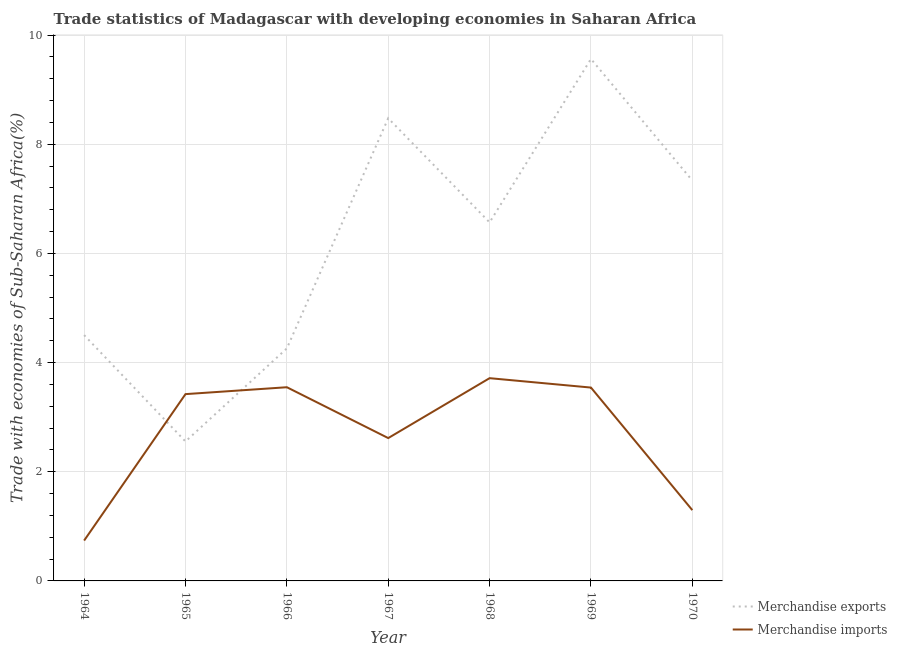How many different coloured lines are there?
Your answer should be very brief. 2. What is the merchandise imports in 1964?
Your answer should be compact. 0.74. Across all years, what is the maximum merchandise imports?
Offer a very short reply. 3.71. Across all years, what is the minimum merchandise imports?
Provide a succinct answer. 0.74. In which year was the merchandise exports maximum?
Make the answer very short. 1969. In which year was the merchandise imports minimum?
Your answer should be very brief. 1964. What is the total merchandise imports in the graph?
Provide a succinct answer. 18.88. What is the difference between the merchandise exports in 1965 and that in 1966?
Give a very brief answer. -1.7. What is the difference between the merchandise exports in 1967 and the merchandise imports in 1970?
Your answer should be compact. 7.18. What is the average merchandise exports per year?
Provide a succinct answer. 6.18. In the year 1968, what is the difference between the merchandise exports and merchandise imports?
Offer a terse response. 2.85. What is the ratio of the merchandise exports in 1965 to that in 1970?
Your answer should be very brief. 0.35. Is the merchandise imports in 1965 less than that in 1969?
Your response must be concise. Yes. Is the difference between the merchandise exports in 1964 and 1968 greater than the difference between the merchandise imports in 1964 and 1968?
Your answer should be very brief. Yes. What is the difference between the highest and the second highest merchandise imports?
Provide a succinct answer. 0.17. What is the difference between the highest and the lowest merchandise exports?
Your response must be concise. 7.01. Is the sum of the merchandise exports in 1964 and 1966 greater than the maximum merchandise imports across all years?
Give a very brief answer. Yes. Is the merchandise exports strictly less than the merchandise imports over the years?
Keep it short and to the point. No. How many lines are there?
Provide a succinct answer. 2. How many years are there in the graph?
Ensure brevity in your answer.  7. Are the values on the major ticks of Y-axis written in scientific E-notation?
Keep it short and to the point. No. Where does the legend appear in the graph?
Make the answer very short. Bottom right. How many legend labels are there?
Provide a succinct answer. 2. What is the title of the graph?
Keep it short and to the point. Trade statistics of Madagascar with developing economies in Saharan Africa. Does "Rural Population" appear as one of the legend labels in the graph?
Provide a short and direct response. No. What is the label or title of the Y-axis?
Make the answer very short. Trade with economies of Sub-Saharan Africa(%). What is the Trade with economies of Sub-Saharan Africa(%) in Merchandise exports in 1964?
Your response must be concise. 4.5. What is the Trade with economies of Sub-Saharan Africa(%) in Merchandise imports in 1964?
Your response must be concise. 0.74. What is the Trade with economies of Sub-Saharan Africa(%) of Merchandise exports in 1965?
Provide a short and direct response. 2.56. What is the Trade with economies of Sub-Saharan Africa(%) in Merchandise imports in 1965?
Provide a short and direct response. 3.42. What is the Trade with economies of Sub-Saharan Africa(%) of Merchandise exports in 1966?
Your response must be concise. 4.26. What is the Trade with economies of Sub-Saharan Africa(%) in Merchandise imports in 1966?
Give a very brief answer. 3.55. What is the Trade with economies of Sub-Saharan Africa(%) of Merchandise exports in 1967?
Give a very brief answer. 8.48. What is the Trade with economies of Sub-Saharan Africa(%) in Merchandise imports in 1967?
Ensure brevity in your answer.  2.62. What is the Trade with economies of Sub-Saharan Africa(%) of Merchandise exports in 1968?
Your answer should be very brief. 6.57. What is the Trade with economies of Sub-Saharan Africa(%) in Merchandise imports in 1968?
Provide a succinct answer. 3.71. What is the Trade with economies of Sub-Saharan Africa(%) of Merchandise exports in 1969?
Offer a terse response. 9.56. What is the Trade with economies of Sub-Saharan Africa(%) in Merchandise imports in 1969?
Provide a succinct answer. 3.54. What is the Trade with economies of Sub-Saharan Africa(%) in Merchandise exports in 1970?
Provide a succinct answer. 7.34. What is the Trade with economies of Sub-Saharan Africa(%) of Merchandise imports in 1970?
Offer a very short reply. 1.3. Across all years, what is the maximum Trade with economies of Sub-Saharan Africa(%) of Merchandise exports?
Your answer should be very brief. 9.56. Across all years, what is the maximum Trade with economies of Sub-Saharan Africa(%) in Merchandise imports?
Provide a succinct answer. 3.71. Across all years, what is the minimum Trade with economies of Sub-Saharan Africa(%) in Merchandise exports?
Offer a very short reply. 2.56. Across all years, what is the minimum Trade with economies of Sub-Saharan Africa(%) in Merchandise imports?
Provide a short and direct response. 0.74. What is the total Trade with economies of Sub-Saharan Africa(%) in Merchandise exports in the graph?
Ensure brevity in your answer.  43.26. What is the total Trade with economies of Sub-Saharan Africa(%) of Merchandise imports in the graph?
Offer a very short reply. 18.88. What is the difference between the Trade with economies of Sub-Saharan Africa(%) of Merchandise exports in 1964 and that in 1965?
Ensure brevity in your answer.  1.95. What is the difference between the Trade with economies of Sub-Saharan Africa(%) in Merchandise imports in 1964 and that in 1965?
Provide a short and direct response. -2.68. What is the difference between the Trade with economies of Sub-Saharan Africa(%) in Merchandise exports in 1964 and that in 1966?
Your answer should be very brief. 0.24. What is the difference between the Trade with economies of Sub-Saharan Africa(%) of Merchandise imports in 1964 and that in 1966?
Offer a very short reply. -2.81. What is the difference between the Trade with economies of Sub-Saharan Africa(%) in Merchandise exports in 1964 and that in 1967?
Your answer should be compact. -3.97. What is the difference between the Trade with economies of Sub-Saharan Africa(%) in Merchandise imports in 1964 and that in 1967?
Make the answer very short. -1.88. What is the difference between the Trade with economies of Sub-Saharan Africa(%) of Merchandise exports in 1964 and that in 1968?
Provide a succinct answer. -2.07. What is the difference between the Trade with economies of Sub-Saharan Africa(%) in Merchandise imports in 1964 and that in 1968?
Keep it short and to the point. -2.98. What is the difference between the Trade with economies of Sub-Saharan Africa(%) of Merchandise exports in 1964 and that in 1969?
Ensure brevity in your answer.  -5.06. What is the difference between the Trade with economies of Sub-Saharan Africa(%) of Merchandise imports in 1964 and that in 1969?
Offer a terse response. -2.8. What is the difference between the Trade with economies of Sub-Saharan Africa(%) in Merchandise exports in 1964 and that in 1970?
Make the answer very short. -2.83. What is the difference between the Trade with economies of Sub-Saharan Africa(%) of Merchandise imports in 1964 and that in 1970?
Ensure brevity in your answer.  -0.56. What is the difference between the Trade with economies of Sub-Saharan Africa(%) of Merchandise exports in 1965 and that in 1966?
Your response must be concise. -1.7. What is the difference between the Trade with economies of Sub-Saharan Africa(%) in Merchandise imports in 1965 and that in 1966?
Offer a terse response. -0.13. What is the difference between the Trade with economies of Sub-Saharan Africa(%) in Merchandise exports in 1965 and that in 1967?
Offer a terse response. -5.92. What is the difference between the Trade with economies of Sub-Saharan Africa(%) in Merchandise imports in 1965 and that in 1967?
Keep it short and to the point. 0.81. What is the difference between the Trade with economies of Sub-Saharan Africa(%) in Merchandise exports in 1965 and that in 1968?
Ensure brevity in your answer.  -4.01. What is the difference between the Trade with economies of Sub-Saharan Africa(%) of Merchandise imports in 1965 and that in 1968?
Keep it short and to the point. -0.29. What is the difference between the Trade with economies of Sub-Saharan Africa(%) in Merchandise exports in 1965 and that in 1969?
Provide a succinct answer. -7.01. What is the difference between the Trade with economies of Sub-Saharan Africa(%) of Merchandise imports in 1965 and that in 1969?
Provide a short and direct response. -0.12. What is the difference between the Trade with economies of Sub-Saharan Africa(%) of Merchandise exports in 1965 and that in 1970?
Your response must be concise. -4.78. What is the difference between the Trade with economies of Sub-Saharan Africa(%) of Merchandise imports in 1965 and that in 1970?
Give a very brief answer. 2.13. What is the difference between the Trade with economies of Sub-Saharan Africa(%) of Merchandise exports in 1966 and that in 1967?
Ensure brevity in your answer.  -4.22. What is the difference between the Trade with economies of Sub-Saharan Africa(%) in Merchandise imports in 1966 and that in 1967?
Offer a terse response. 0.93. What is the difference between the Trade with economies of Sub-Saharan Africa(%) in Merchandise exports in 1966 and that in 1968?
Your answer should be compact. -2.31. What is the difference between the Trade with economies of Sub-Saharan Africa(%) of Merchandise imports in 1966 and that in 1968?
Provide a succinct answer. -0.17. What is the difference between the Trade with economies of Sub-Saharan Africa(%) in Merchandise exports in 1966 and that in 1969?
Keep it short and to the point. -5.3. What is the difference between the Trade with economies of Sub-Saharan Africa(%) in Merchandise imports in 1966 and that in 1969?
Offer a terse response. 0.01. What is the difference between the Trade with economies of Sub-Saharan Africa(%) of Merchandise exports in 1966 and that in 1970?
Your response must be concise. -3.08. What is the difference between the Trade with economies of Sub-Saharan Africa(%) in Merchandise imports in 1966 and that in 1970?
Offer a terse response. 2.25. What is the difference between the Trade with economies of Sub-Saharan Africa(%) of Merchandise exports in 1967 and that in 1968?
Your response must be concise. 1.91. What is the difference between the Trade with economies of Sub-Saharan Africa(%) of Merchandise imports in 1967 and that in 1968?
Keep it short and to the point. -1.1. What is the difference between the Trade with economies of Sub-Saharan Africa(%) in Merchandise exports in 1967 and that in 1969?
Provide a succinct answer. -1.09. What is the difference between the Trade with economies of Sub-Saharan Africa(%) of Merchandise imports in 1967 and that in 1969?
Give a very brief answer. -0.93. What is the difference between the Trade with economies of Sub-Saharan Africa(%) in Merchandise exports in 1967 and that in 1970?
Your answer should be compact. 1.14. What is the difference between the Trade with economies of Sub-Saharan Africa(%) in Merchandise imports in 1967 and that in 1970?
Your answer should be very brief. 1.32. What is the difference between the Trade with economies of Sub-Saharan Africa(%) of Merchandise exports in 1968 and that in 1969?
Your answer should be compact. -2.99. What is the difference between the Trade with economies of Sub-Saharan Africa(%) in Merchandise imports in 1968 and that in 1969?
Your answer should be compact. 0.17. What is the difference between the Trade with economies of Sub-Saharan Africa(%) of Merchandise exports in 1968 and that in 1970?
Your response must be concise. -0.77. What is the difference between the Trade with economies of Sub-Saharan Africa(%) of Merchandise imports in 1968 and that in 1970?
Your answer should be very brief. 2.42. What is the difference between the Trade with economies of Sub-Saharan Africa(%) in Merchandise exports in 1969 and that in 1970?
Make the answer very short. 2.23. What is the difference between the Trade with economies of Sub-Saharan Africa(%) of Merchandise imports in 1969 and that in 1970?
Your answer should be very brief. 2.25. What is the difference between the Trade with economies of Sub-Saharan Africa(%) in Merchandise exports in 1964 and the Trade with economies of Sub-Saharan Africa(%) in Merchandise imports in 1965?
Your response must be concise. 1.08. What is the difference between the Trade with economies of Sub-Saharan Africa(%) in Merchandise exports in 1964 and the Trade with economies of Sub-Saharan Africa(%) in Merchandise imports in 1966?
Make the answer very short. 0.95. What is the difference between the Trade with economies of Sub-Saharan Africa(%) of Merchandise exports in 1964 and the Trade with economies of Sub-Saharan Africa(%) of Merchandise imports in 1967?
Provide a succinct answer. 1.89. What is the difference between the Trade with economies of Sub-Saharan Africa(%) of Merchandise exports in 1964 and the Trade with economies of Sub-Saharan Africa(%) of Merchandise imports in 1968?
Make the answer very short. 0.79. What is the difference between the Trade with economies of Sub-Saharan Africa(%) in Merchandise exports in 1964 and the Trade with economies of Sub-Saharan Africa(%) in Merchandise imports in 1969?
Provide a succinct answer. 0.96. What is the difference between the Trade with economies of Sub-Saharan Africa(%) in Merchandise exports in 1964 and the Trade with economies of Sub-Saharan Africa(%) in Merchandise imports in 1970?
Offer a terse response. 3.21. What is the difference between the Trade with economies of Sub-Saharan Africa(%) of Merchandise exports in 1965 and the Trade with economies of Sub-Saharan Africa(%) of Merchandise imports in 1966?
Provide a succinct answer. -0.99. What is the difference between the Trade with economies of Sub-Saharan Africa(%) in Merchandise exports in 1965 and the Trade with economies of Sub-Saharan Africa(%) in Merchandise imports in 1967?
Keep it short and to the point. -0.06. What is the difference between the Trade with economies of Sub-Saharan Africa(%) in Merchandise exports in 1965 and the Trade with economies of Sub-Saharan Africa(%) in Merchandise imports in 1968?
Your response must be concise. -1.16. What is the difference between the Trade with economies of Sub-Saharan Africa(%) in Merchandise exports in 1965 and the Trade with economies of Sub-Saharan Africa(%) in Merchandise imports in 1969?
Make the answer very short. -0.99. What is the difference between the Trade with economies of Sub-Saharan Africa(%) in Merchandise exports in 1965 and the Trade with economies of Sub-Saharan Africa(%) in Merchandise imports in 1970?
Make the answer very short. 1.26. What is the difference between the Trade with economies of Sub-Saharan Africa(%) in Merchandise exports in 1966 and the Trade with economies of Sub-Saharan Africa(%) in Merchandise imports in 1967?
Give a very brief answer. 1.64. What is the difference between the Trade with economies of Sub-Saharan Africa(%) of Merchandise exports in 1966 and the Trade with economies of Sub-Saharan Africa(%) of Merchandise imports in 1968?
Your response must be concise. 0.55. What is the difference between the Trade with economies of Sub-Saharan Africa(%) of Merchandise exports in 1966 and the Trade with economies of Sub-Saharan Africa(%) of Merchandise imports in 1969?
Your answer should be compact. 0.72. What is the difference between the Trade with economies of Sub-Saharan Africa(%) in Merchandise exports in 1966 and the Trade with economies of Sub-Saharan Africa(%) in Merchandise imports in 1970?
Your response must be concise. 2.96. What is the difference between the Trade with economies of Sub-Saharan Africa(%) of Merchandise exports in 1967 and the Trade with economies of Sub-Saharan Africa(%) of Merchandise imports in 1968?
Give a very brief answer. 4.76. What is the difference between the Trade with economies of Sub-Saharan Africa(%) of Merchandise exports in 1967 and the Trade with economies of Sub-Saharan Africa(%) of Merchandise imports in 1969?
Your answer should be very brief. 4.93. What is the difference between the Trade with economies of Sub-Saharan Africa(%) of Merchandise exports in 1967 and the Trade with economies of Sub-Saharan Africa(%) of Merchandise imports in 1970?
Offer a very short reply. 7.18. What is the difference between the Trade with economies of Sub-Saharan Africa(%) in Merchandise exports in 1968 and the Trade with economies of Sub-Saharan Africa(%) in Merchandise imports in 1969?
Give a very brief answer. 3.03. What is the difference between the Trade with economies of Sub-Saharan Africa(%) of Merchandise exports in 1968 and the Trade with economies of Sub-Saharan Africa(%) of Merchandise imports in 1970?
Provide a succinct answer. 5.27. What is the difference between the Trade with economies of Sub-Saharan Africa(%) of Merchandise exports in 1969 and the Trade with economies of Sub-Saharan Africa(%) of Merchandise imports in 1970?
Give a very brief answer. 8.27. What is the average Trade with economies of Sub-Saharan Africa(%) in Merchandise exports per year?
Give a very brief answer. 6.18. What is the average Trade with economies of Sub-Saharan Africa(%) of Merchandise imports per year?
Keep it short and to the point. 2.7. In the year 1964, what is the difference between the Trade with economies of Sub-Saharan Africa(%) in Merchandise exports and Trade with economies of Sub-Saharan Africa(%) in Merchandise imports?
Give a very brief answer. 3.76. In the year 1965, what is the difference between the Trade with economies of Sub-Saharan Africa(%) in Merchandise exports and Trade with economies of Sub-Saharan Africa(%) in Merchandise imports?
Your answer should be very brief. -0.87. In the year 1966, what is the difference between the Trade with economies of Sub-Saharan Africa(%) in Merchandise exports and Trade with economies of Sub-Saharan Africa(%) in Merchandise imports?
Give a very brief answer. 0.71. In the year 1967, what is the difference between the Trade with economies of Sub-Saharan Africa(%) in Merchandise exports and Trade with economies of Sub-Saharan Africa(%) in Merchandise imports?
Provide a short and direct response. 5.86. In the year 1968, what is the difference between the Trade with economies of Sub-Saharan Africa(%) of Merchandise exports and Trade with economies of Sub-Saharan Africa(%) of Merchandise imports?
Your answer should be compact. 2.85. In the year 1969, what is the difference between the Trade with economies of Sub-Saharan Africa(%) of Merchandise exports and Trade with economies of Sub-Saharan Africa(%) of Merchandise imports?
Make the answer very short. 6.02. In the year 1970, what is the difference between the Trade with economies of Sub-Saharan Africa(%) of Merchandise exports and Trade with economies of Sub-Saharan Africa(%) of Merchandise imports?
Offer a very short reply. 6.04. What is the ratio of the Trade with economies of Sub-Saharan Africa(%) of Merchandise exports in 1964 to that in 1965?
Provide a succinct answer. 1.76. What is the ratio of the Trade with economies of Sub-Saharan Africa(%) of Merchandise imports in 1964 to that in 1965?
Give a very brief answer. 0.22. What is the ratio of the Trade with economies of Sub-Saharan Africa(%) in Merchandise exports in 1964 to that in 1966?
Ensure brevity in your answer.  1.06. What is the ratio of the Trade with economies of Sub-Saharan Africa(%) of Merchandise imports in 1964 to that in 1966?
Keep it short and to the point. 0.21. What is the ratio of the Trade with economies of Sub-Saharan Africa(%) of Merchandise exports in 1964 to that in 1967?
Provide a short and direct response. 0.53. What is the ratio of the Trade with economies of Sub-Saharan Africa(%) in Merchandise imports in 1964 to that in 1967?
Keep it short and to the point. 0.28. What is the ratio of the Trade with economies of Sub-Saharan Africa(%) in Merchandise exports in 1964 to that in 1968?
Offer a very short reply. 0.69. What is the ratio of the Trade with economies of Sub-Saharan Africa(%) in Merchandise imports in 1964 to that in 1968?
Make the answer very short. 0.2. What is the ratio of the Trade with economies of Sub-Saharan Africa(%) of Merchandise exports in 1964 to that in 1969?
Make the answer very short. 0.47. What is the ratio of the Trade with economies of Sub-Saharan Africa(%) of Merchandise imports in 1964 to that in 1969?
Make the answer very short. 0.21. What is the ratio of the Trade with economies of Sub-Saharan Africa(%) in Merchandise exports in 1964 to that in 1970?
Make the answer very short. 0.61. What is the ratio of the Trade with economies of Sub-Saharan Africa(%) in Merchandise imports in 1964 to that in 1970?
Offer a terse response. 0.57. What is the ratio of the Trade with economies of Sub-Saharan Africa(%) of Merchandise exports in 1965 to that in 1966?
Provide a succinct answer. 0.6. What is the ratio of the Trade with economies of Sub-Saharan Africa(%) of Merchandise imports in 1965 to that in 1966?
Keep it short and to the point. 0.96. What is the ratio of the Trade with economies of Sub-Saharan Africa(%) of Merchandise exports in 1965 to that in 1967?
Provide a succinct answer. 0.3. What is the ratio of the Trade with economies of Sub-Saharan Africa(%) in Merchandise imports in 1965 to that in 1967?
Ensure brevity in your answer.  1.31. What is the ratio of the Trade with economies of Sub-Saharan Africa(%) of Merchandise exports in 1965 to that in 1968?
Your answer should be compact. 0.39. What is the ratio of the Trade with economies of Sub-Saharan Africa(%) in Merchandise imports in 1965 to that in 1968?
Provide a short and direct response. 0.92. What is the ratio of the Trade with economies of Sub-Saharan Africa(%) in Merchandise exports in 1965 to that in 1969?
Your response must be concise. 0.27. What is the ratio of the Trade with economies of Sub-Saharan Africa(%) in Merchandise imports in 1965 to that in 1969?
Give a very brief answer. 0.97. What is the ratio of the Trade with economies of Sub-Saharan Africa(%) in Merchandise exports in 1965 to that in 1970?
Your answer should be compact. 0.35. What is the ratio of the Trade with economies of Sub-Saharan Africa(%) in Merchandise imports in 1965 to that in 1970?
Your answer should be compact. 2.64. What is the ratio of the Trade with economies of Sub-Saharan Africa(%) in Merchandise exports in 1966 to that in 1967?
Offer a very short reply. 0.5. What is the ratio of the Trade with economies of Sub-Saharan Africa(%) of Merchandise imports in 1966 to that in 1967?
Your answer should be very brief. 1.36. What is the ratio of the Trade with economies of Sub-Saharan Africa(%) in Merchandise exports in 1966 to that in 1968?
Make the answer very short. 0.65. What is the ratio of the Trade with economies of Sub-Saharan Africa(%) of Merchandise imports in 1966 to that in 1968?
Give a very brief answer. 0.96. What is the ratio of the Trade with economies of Sub-Saharan Africa(%) of Merchandise exports in 1966 to that in 1969?
Offer a terse response. 0.45. What is the ratio of the Trade with economies of Sub-Saharan Africa(%) in Merchandise exports in 1966 to that in 1970?
Your response must be concise. 0.58. What is the ratio of the Trade with economies of Sub-Saharan Africa(%) of Merchandise imports in 1966 to that in 1970?
Provide a short and direct response. 2.74. What is the ratio of the Trade with economies of Sub-Saharan Africa(%) in Merchandise exports in 1967 to that in 1968?
Ensure brevity in your answer.  1.29. What is the ratio of the Trade with economies of Sub-Saharan Africa(%) of Merchandise imports in 1967 to that in 1968?
Make the answer very short. 0.7. What is the ratio of the Trade with economies of Sub-Saharan Africa(%) of Merchandise exports in 1967 to that in 1969?
Your answer should be compact. 0.89. What is the ratio of the Trade with economies of Sub-Saharan Africa(%) of Merchandise imports in 1967 to that in 1969?
Keep it short and to the point. 0.74. What is the ratio of the Trade with economies of Sub-Saharan Africa(%) of Merchandise exports in 1967 to that in 1970?
Your answer should be very brief. 1.16. What is the ratio of the Trade with economies of Sub-Saharan Africa(%) in Merchandise imports in 1967 to that in 1970?
Provide a short and direct response. 2.02. What is the ratio of the Trade with economies of Sub-Saharan Africa(%) in Merchandise exports in 1968 to that in 1969?
Provide a short and direct response. 0.69. What is the ratio of the Trade with economies of Sub-Saharan Africa(%) in Merchandise imports in 1968 to that in 1969?
Keep it short and to the point. 1.05. What is the ratio of the Trade with economies of Sub-Saharan Africa(%) in Merchandise exports in 1968 to that in 1970?
Your response must be concise. 0.9. What is the ratio of the Trade with economies of Sub-Saharan Africa(%) of Merchandise imports in 1968 to that in 1970?
Offer a very short reply. 2.86. What is the ratio of the Trade with economies of Sub-Saharan Africa(%) in Merchandise exports in 1969 to that in 1970?
Provide a succinct answer. 1.3. What is the ratio of the Trade with economies of Sub-Saharan Africa(%) in Merchandise imports in 1969 to that in 1970?
Keep it short and to the point. 2.73. What is the difference between the highest and the second highest Trade with economies of Sub-Saharan Africa(%) of Merchandise exports?
Keep it short and to the point. 1.09. What is the difference between the highest and the second highest Trade with economies of Sub-Saharan Africa(%) in Merchandise imports?
Provide a short and direct response. 0.17. What is the difference between the highest and the lowest Trade with economies of Sub-Saharan Africa(%) of Merchandise exports?
Offer a very short reply. 7.01. What is the difference between the highest and the lowest Trade with economies of Sub-Saharan Africa(%) of Merchandise imports?
Give a very brief answer. 2.98. 